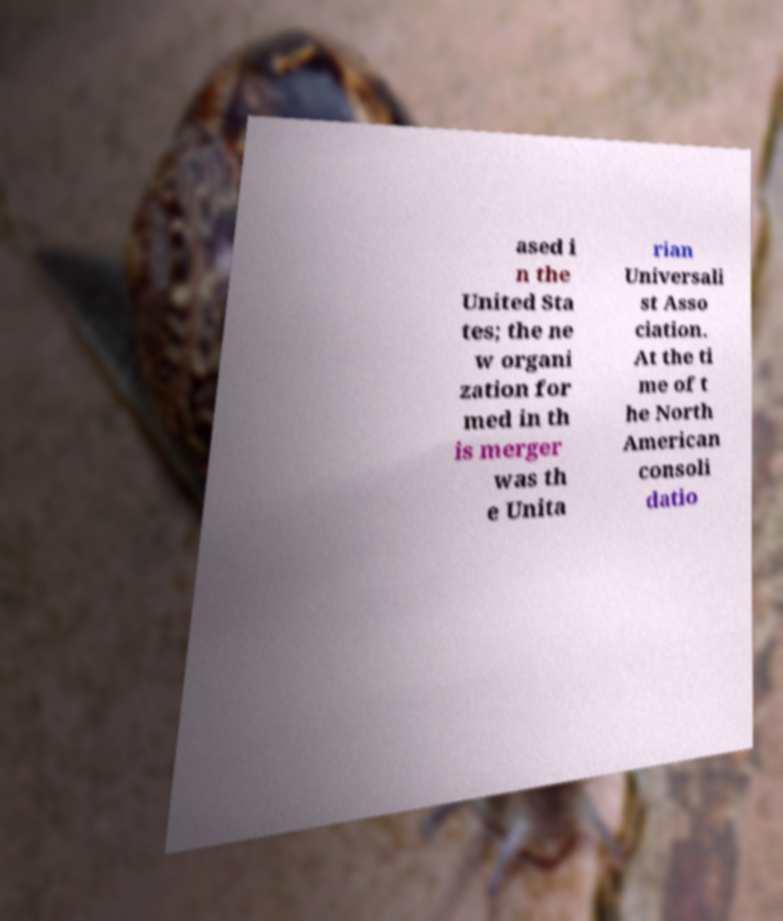What messages or text are displayed in this image? I need them in a readable, typed format. ased i n the United Sta tes; the ne w organi zation for med in th is merger was th e Unita rian Universali st Asso ciation. At the ti me of t he North American consoli datio 